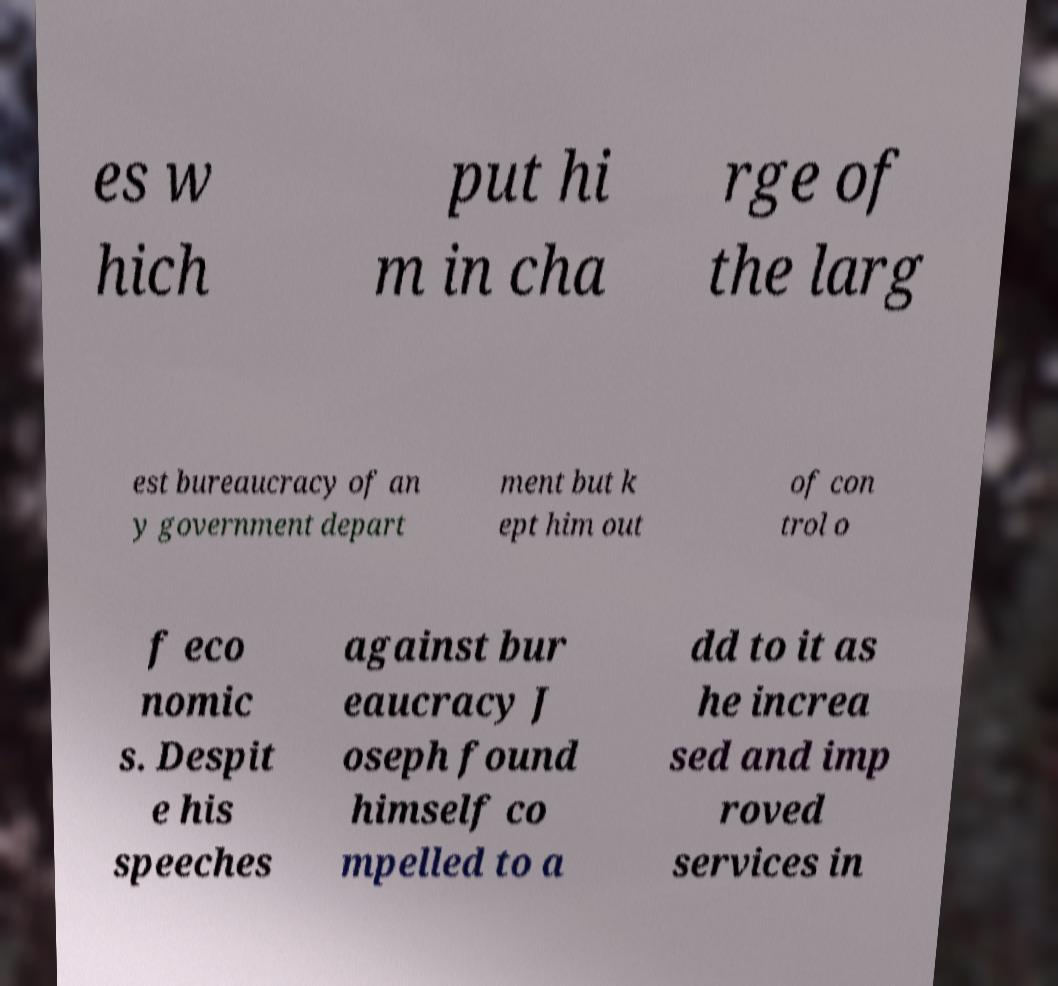I need the written content from this picture converted into text. Can you do that? es w hich put hi m in cha rge of the larg est bureaucracy of an y government depart ment but k ept him out of con trol o f eco nomic s. Despit e his speeches against bur eaucracy J oseph found himself co mpelled to a dd to it as he increa sed and imp roved services in 